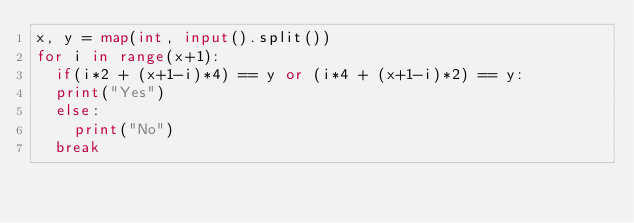Convert code to text. <code><loc_0><loc_0><loc_500><loc_500><_Python_>x, y = map(int, input().split())
for i in range(x+1):
  if(i*2 + (x+1-i)*4) == y or (i*4 + (x+1-i)*2) == y:
	print("Yes")
  else:
    print("No")
  break</code> 